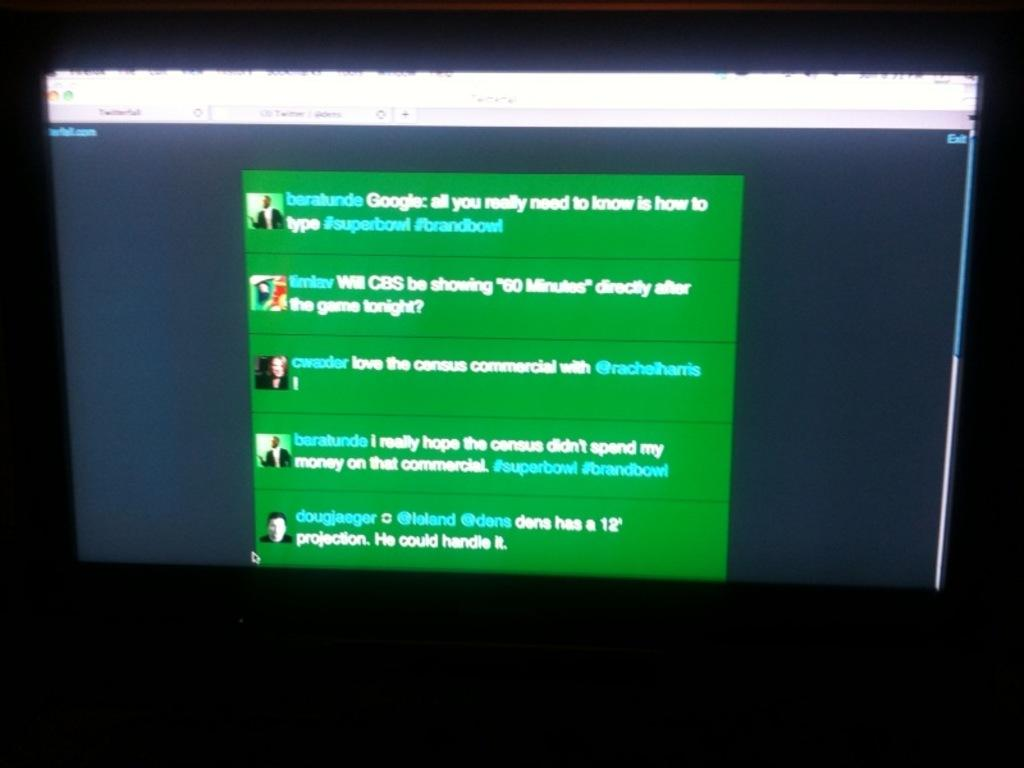Provide a one-sentence caption for the provided image. a monitor open to a green screen with words Google on it. 